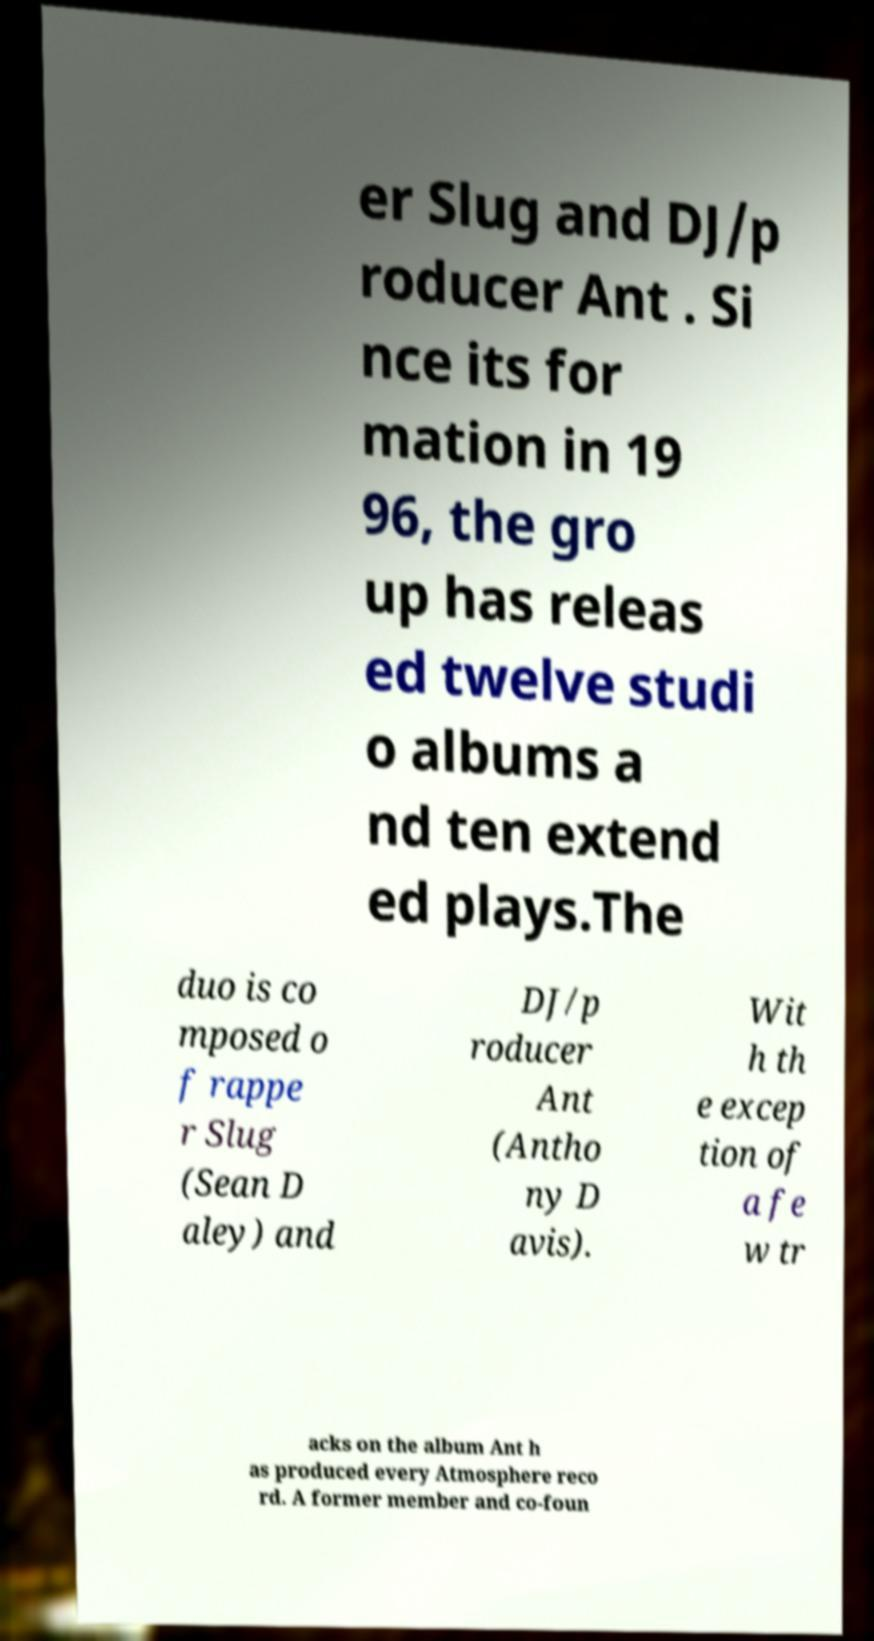For documentation purposes, I need the text within this image transcribed. Could you provide that? er Slug and DJ/p roducer Ant . Si nce its for mation in 19 96, the gro up has releas ed twelve studi o albums a nd ten extend ed plays.The duo is co mposed o f rappe r Slug (Sean D aley) and DJ/p roducer Ant (Antho ny D avis). Wit h th e excep tion of a fe w tr acks on the album Ant h as produced every Atmosphere reco rd. A former member and co-foun 